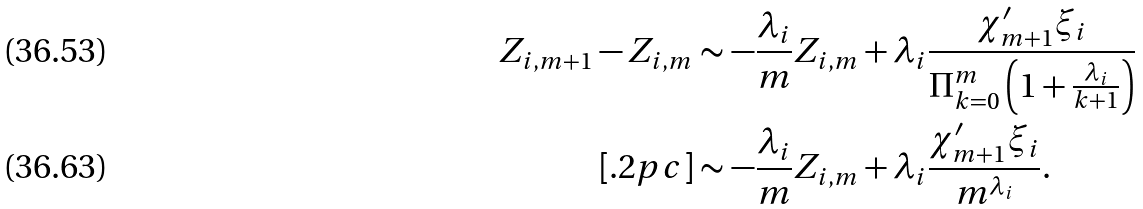Convert formula to latex. <formula><loc_0><loc_0><loc_500><loc_500>Z _ { i , m + 1 } - Z _ { i , m } & \sim - \frac { \lambda _ { i } } { m } Z _ { i , m } + \lambda _ { i } \frac { \chi _ { m + 1 } ^ { \prime } \xi _ { i } } { \Pi _ { k = 0 } ^ { m } \left ( 1 + \frac { \lambda _ { i } } { k + 1 } \right ) } \\ [ . 2 p c ] & \sim - \frac { \lambda _ { i } } { m } Z _ { i , m } + \lambda _ { i } \frac { \chi _ { m + 1 } ^ { \prime } \xi _ { i } } { m ^ { \lambda _ { i } } } .</formula> 